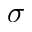<formula> <loc_0><loc_0><loc_500><loc_500>\sigma</formula> 